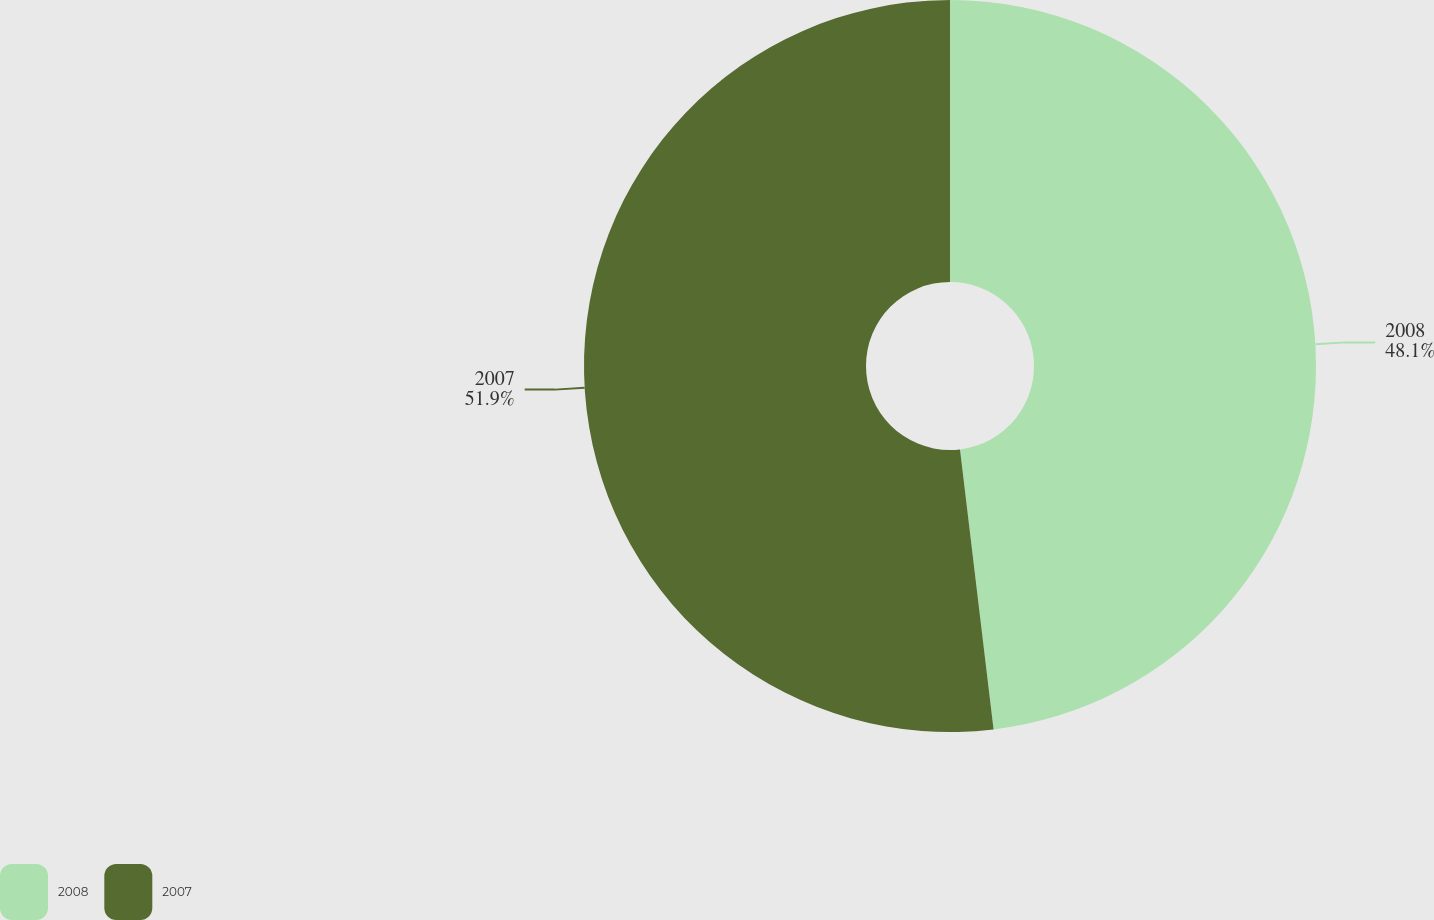Convert chart to OTSL. <chart><loc_0><loc_0><loc_500><loc_500><pie_chart><fcel>2008<fcel>2007<nl><fcel>48.1%<fcel>51.9%<nl></chart> 